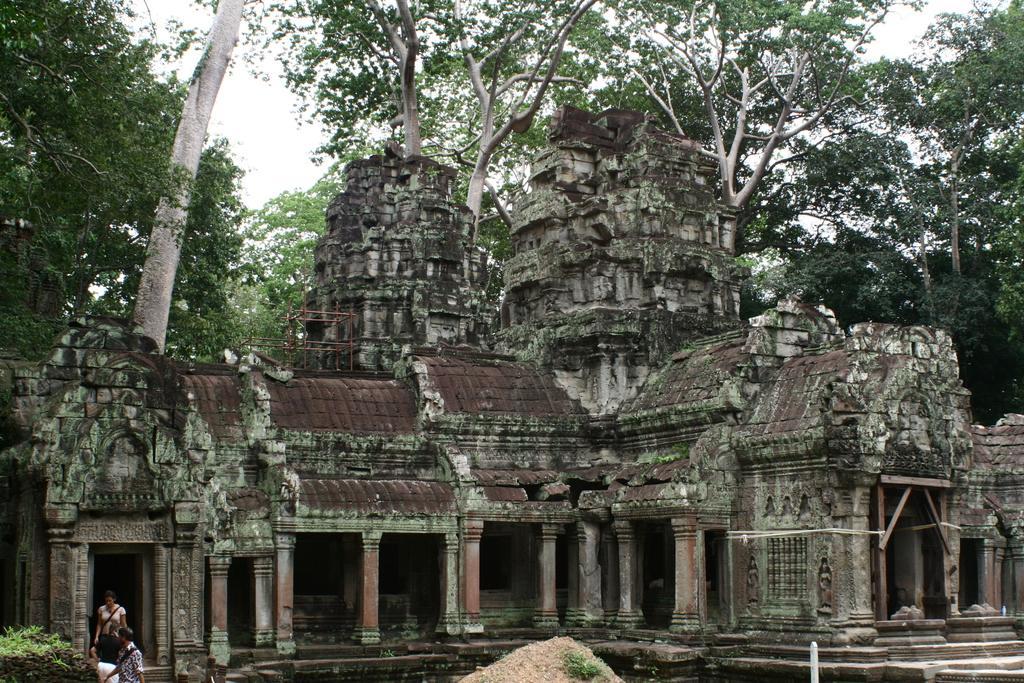Could you give a brief overview of what you see in this image? In this image, I can see an ancient temple. At the bottom of the image, I can see sand, three persons standing and plants. In the background, there are trees and the sky. 